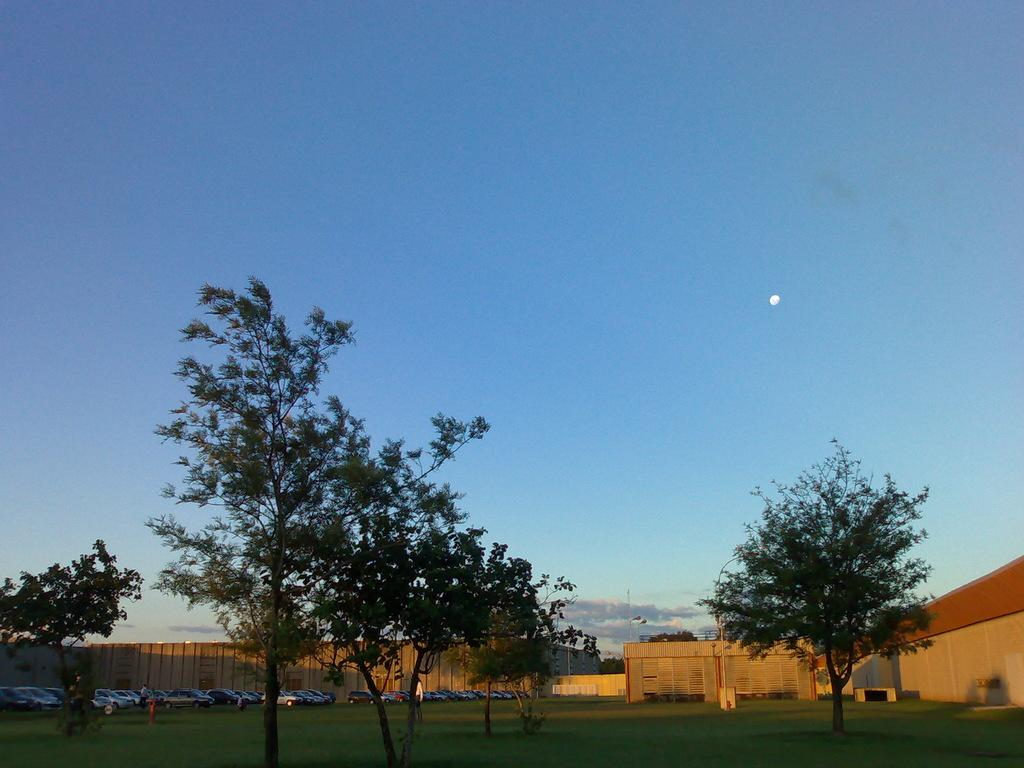What type of natural elements can be seen in the image? There are trees in the image. What man-made objects are present in the image? There are cars and a building visible in the image. What is the color of the sky in the image? The sky is blue and white in color. What flavor of pizzas can be seen being ordered in the image? There is no mention of pizzas or ordering in the image; it features trees, cars, a building, and a blue and white sky. 